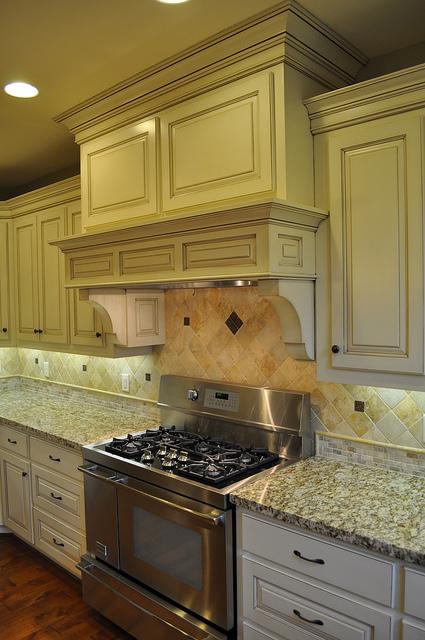What material is the floor?
Short answer required. Wood. How tall are the ceiling in this room?
Short answer required. 10 feet. How many burners are on the stove?
Keep it brief. 4. Is that a gas or electric range?
Quick response, please. Gas. 